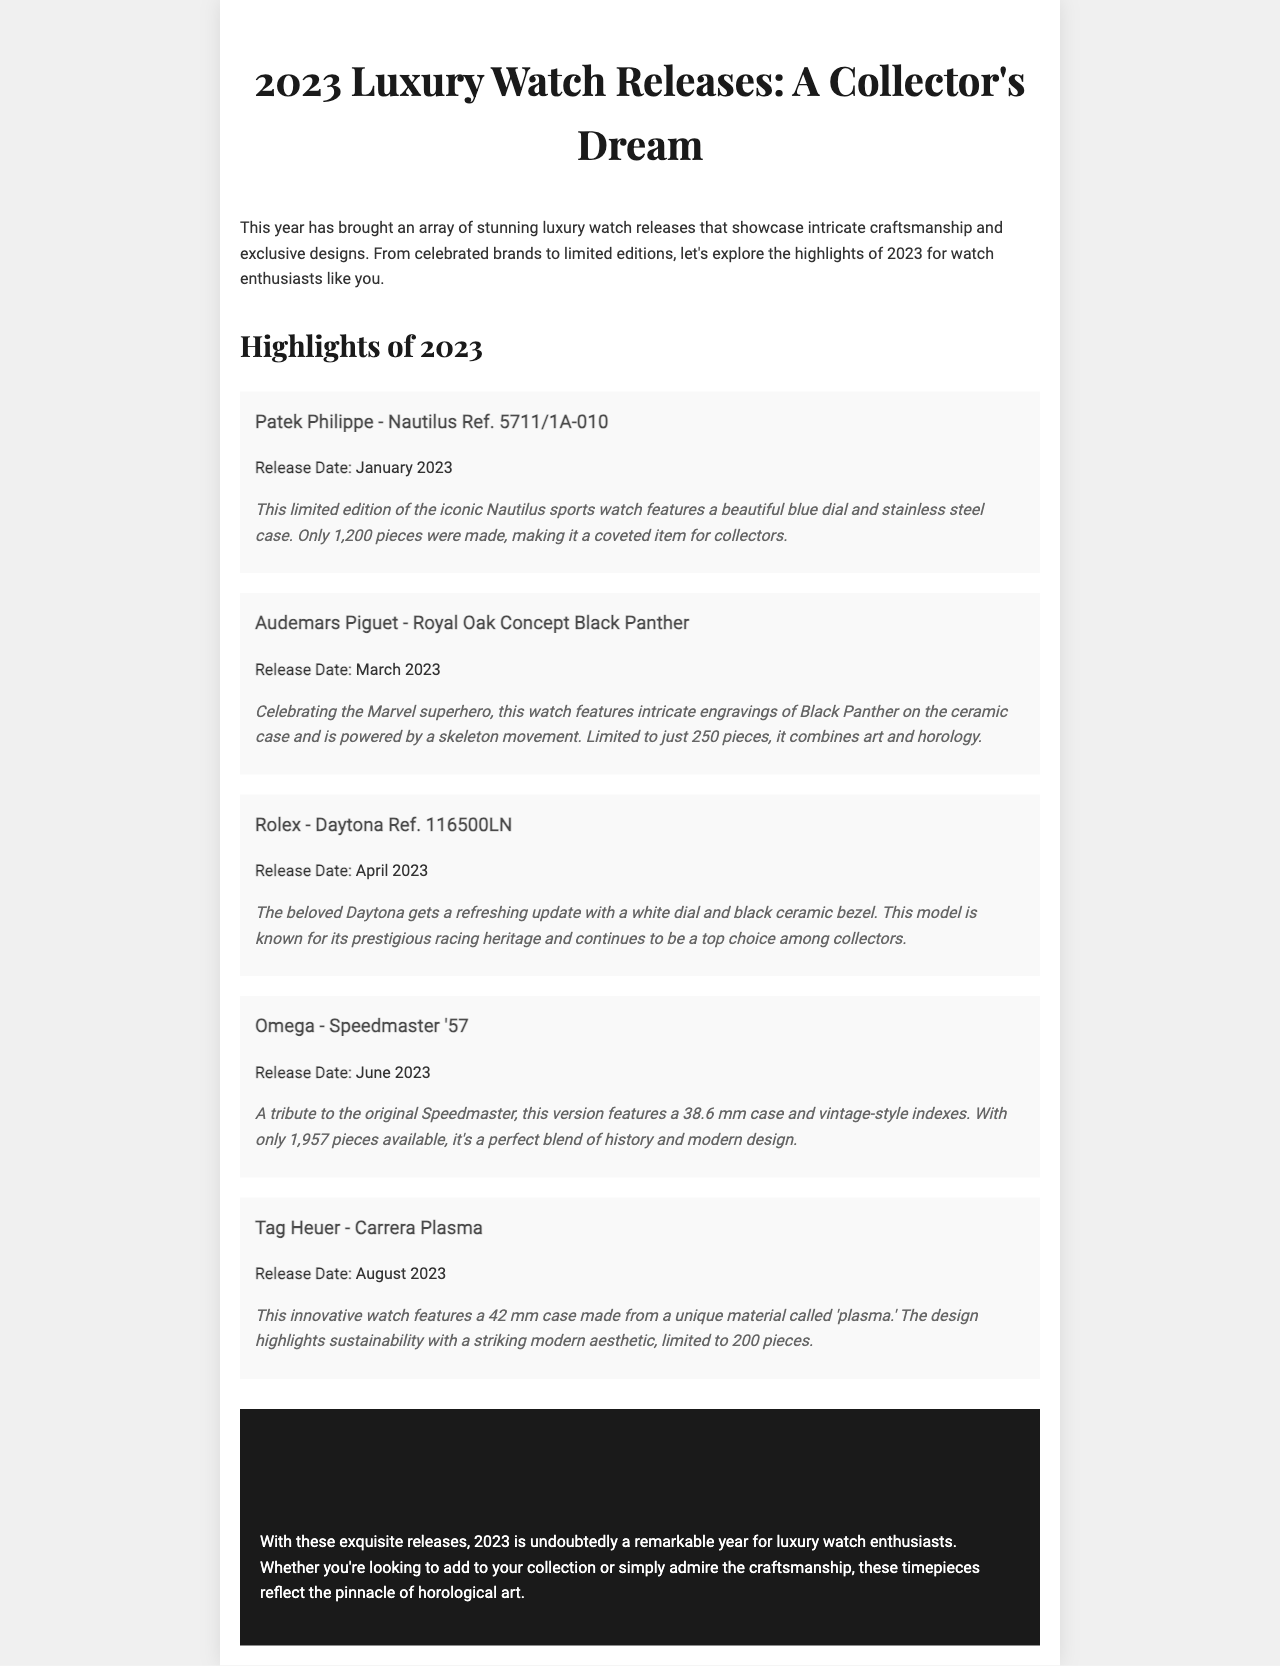What is the release date of the Patek Philippe Nautilus? The release date is mentioned in the document as January 2023.
Answer: January 2023 How many pieces of the Audemars Piguet Black Panther were made? This information indicates that only 250 pieces of the watch were produced, making it a limited edition.
Answer: 250 pieces What is the key feature of the Omega Speedmaster '57? The document notes that this model pays tribute to the original Speedmaster with a classic design and features vintage-style indexes.
Answer: Vintage-style indexes Who is celebrated in the Audemars Piguet watch design? According to the document, the watch designs celebrate the Marvel superhero Black Panther.
Answer: Black Panther What material is used in the Tag Heuer Carrera Plasma? The document specifies that the watch features a unique material called 'plasma.'
Answer: Plasma Which luxury watch brand released a model in April 2023? The document lists Rolex as the brand that released the Daytona in April 2023.
Answer: Rolex Why is the Daytona model significant? The document highlights its renowned racing heritage, underscoring its importance in watch collecting.
Answer: Racing heritage How many pieces are there of the Omega Speedmaster '57? The document clarifies that there are only 1,957 pieces available of this model.
Answer: 1,957 pieces 